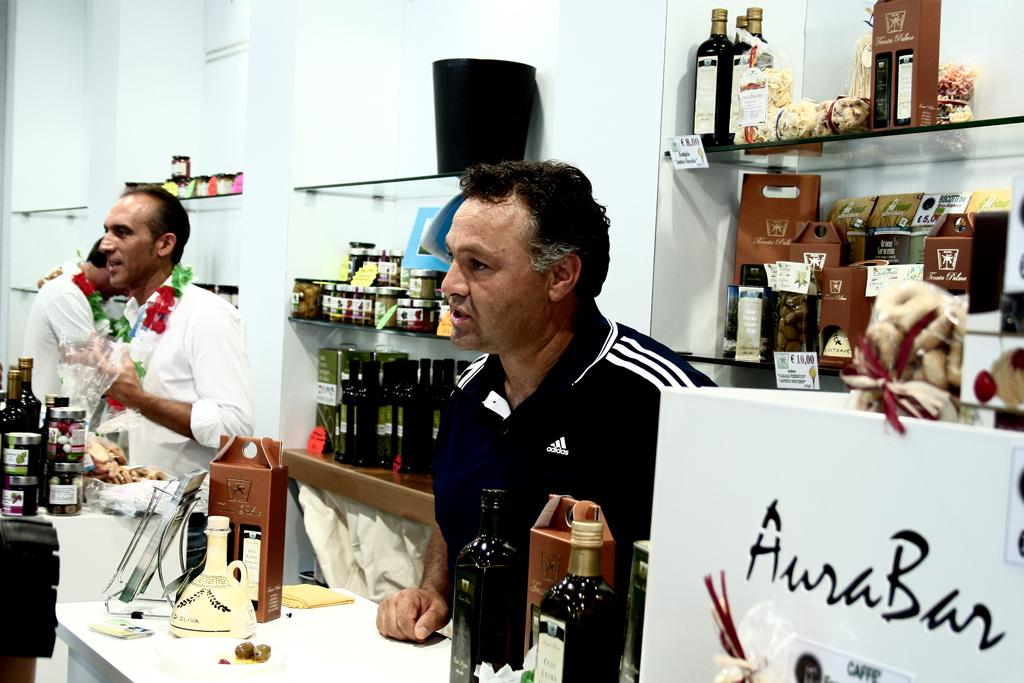<image>
Summarize the visual content of the image. Men standing behind a counter looking at something off camera and there is a white box that says AuraBan on it. 